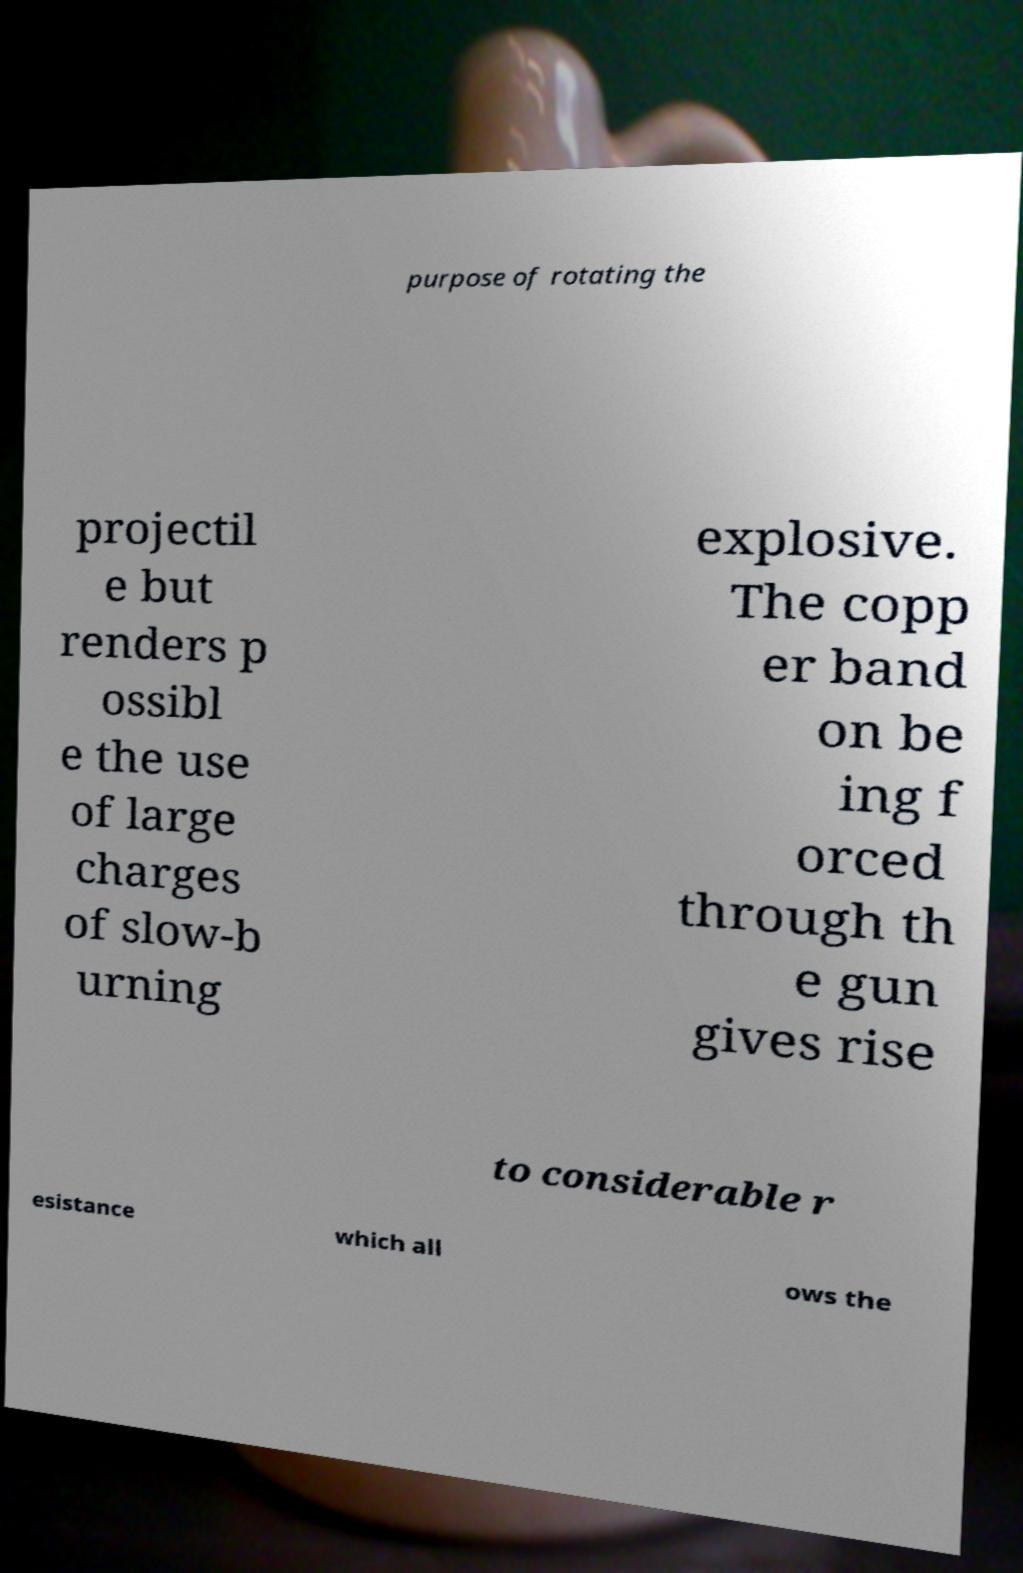Please identify and transcribe the text found in this image. purpose of rotating the projectil e but renders p ossibl e the use of large charges of slow-b urning explosive. The copp er band on be ing f orced through th e gun gives rise to considerable r esistance which all ows the 